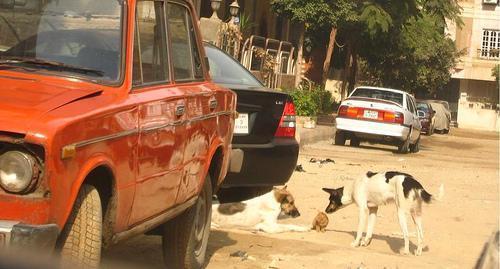How many animals are there?
Give a very brief answer. 2. How many cars can be seen?
Give a very brief answer. 3. How many dogs are there?
Give a very brief answer. 2. How many cakes are on top of the cake caddy?
Give a very brief answer. 0. 